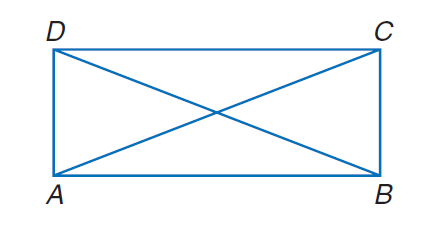Question: A B C D is a rectangle. If A C = 30 - x and B D = 4 x - 60, find x.
Choices:
A. 2
B. 9
C. 18
D. 36
Answer with the letter. Answer: C 